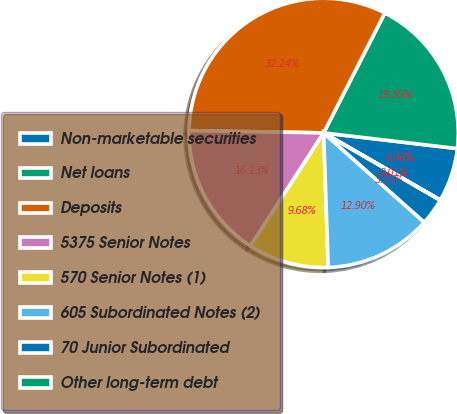Convert chart. <chart><loc_0><loc_0><loc_500><loc_500><pie_chart><fcel>Non-marketable securities<fcel>Net loans<fcel>Deposits<fcel>5375 Senior Notes<fcel>570 Senior Notes (1)<fcel>605 Subordinated Notes (2)<fcel>70 Junior Subordinated<fcel>Other long-term debt<nl><fcel>6.46%<fcel>19.35%<fcel>32.24%<fcel>16.13%<fcel>9.68%<fcel>12.9%<fcel>3.23%<fcel>0.01%<nl></chart> 